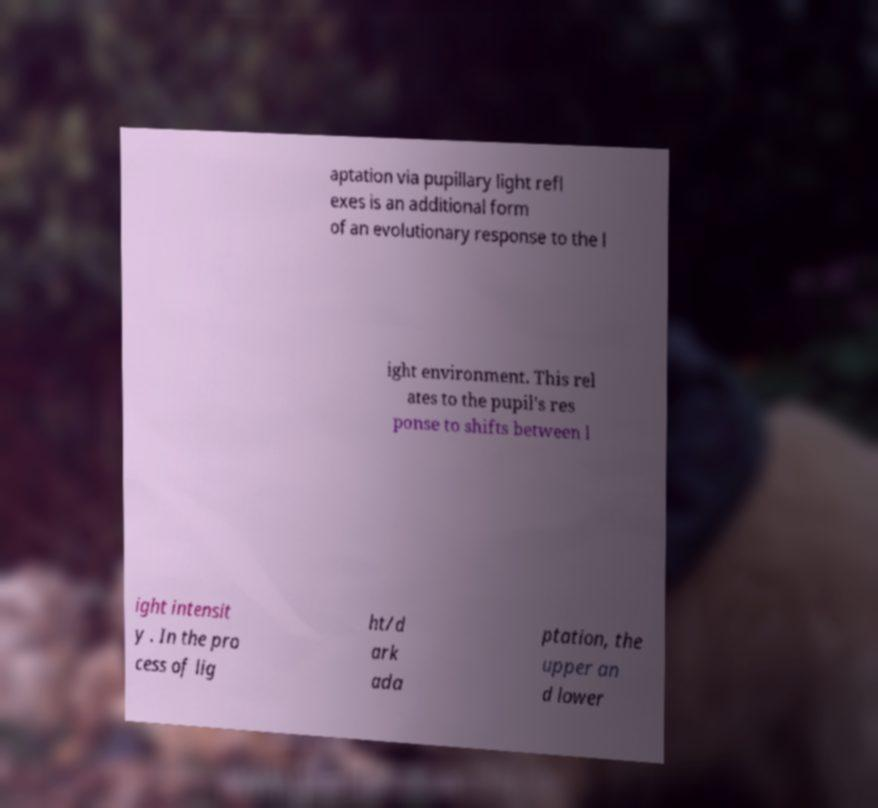Can you read and provide the text displayed in the image?This photo seems to have some interesting text. Can you extract and type it out for me? aptation via pupillary light refl exes is an additional form of an evolutionary response to the l ight environment. This rel ates to the pupil's res ponse to shifts between l ight intensit y . In the pro cess of lig ht/d ark ada ptation, the upper an d lower 